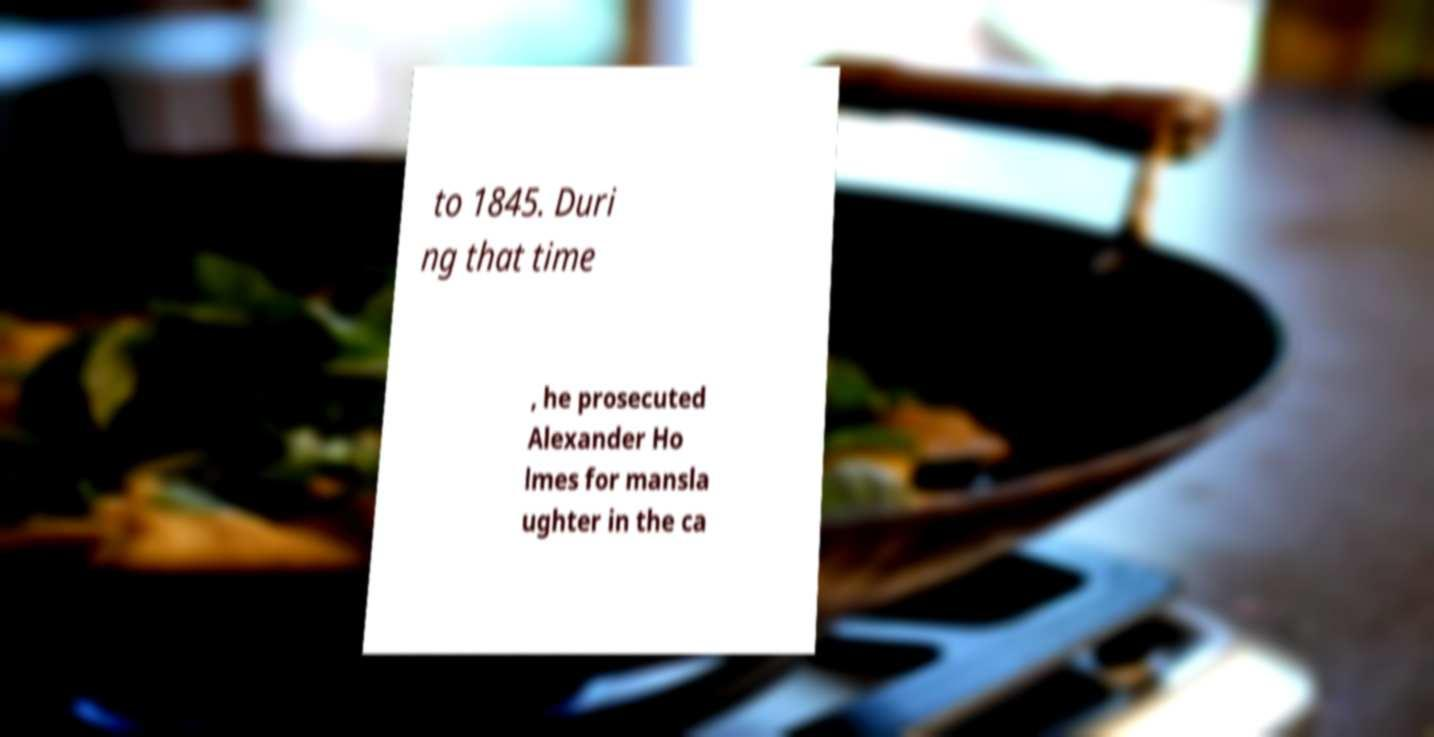Please identify and transcribe the text found in this image. to 1845. Duri ng that time , he prosecuted Alexander Ho lmes for mansla ughter in the ca 